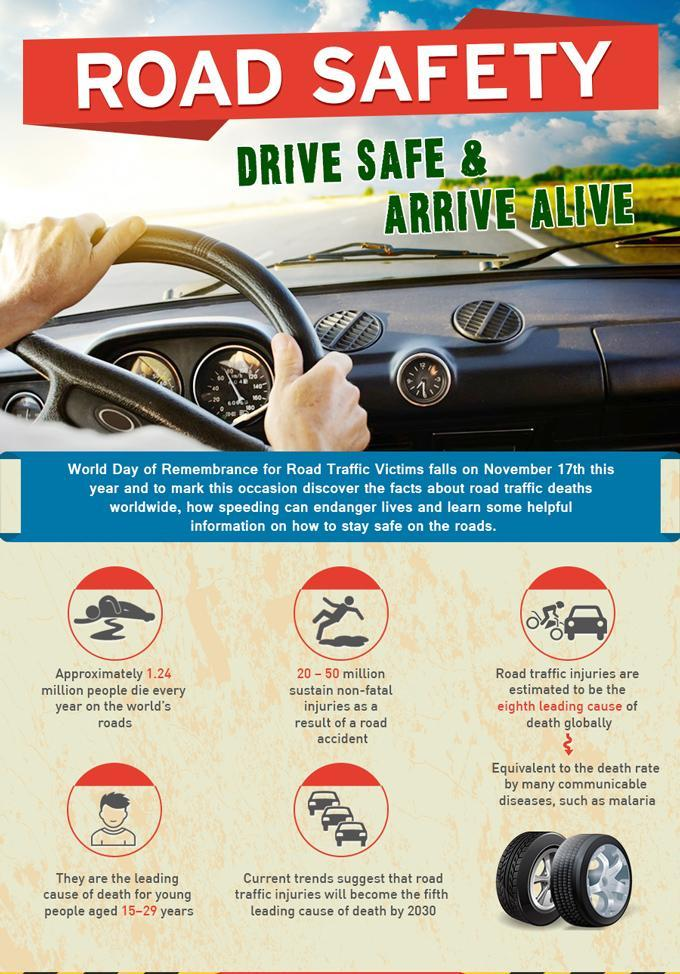What is the leading cause for young people aged 15-29 years?
Answer the question with a short phrase. Road traffic injuries What is the eighth leading cause of death globally other than road traffic injuries? communicable diseases such as malaria 